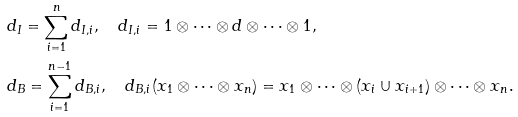<formula> <loc_0><loc_0><loc_500><loc_500>& d _ { I } = \sum _ { i = 1 } ^ { n } d _ { I , i } , \quad d _ { I , i } = 1 \otimes \cdots \otimes d \otimes \cdots \otimes 1 , \\ & d _ { B } = \sum _ { i = 1 } ^ { n - 1 } d _ { B , i } , \quad d _ { B , i } ( x _ { 1 } \otimes \cdots \otimes x _ { n } ) = x _ { 1 } \otimes \cdots \otimes ( x _ { i } \cup x _ { i + 1 } ) \otimes \cdots \otimes x _ { n } .</formula> 